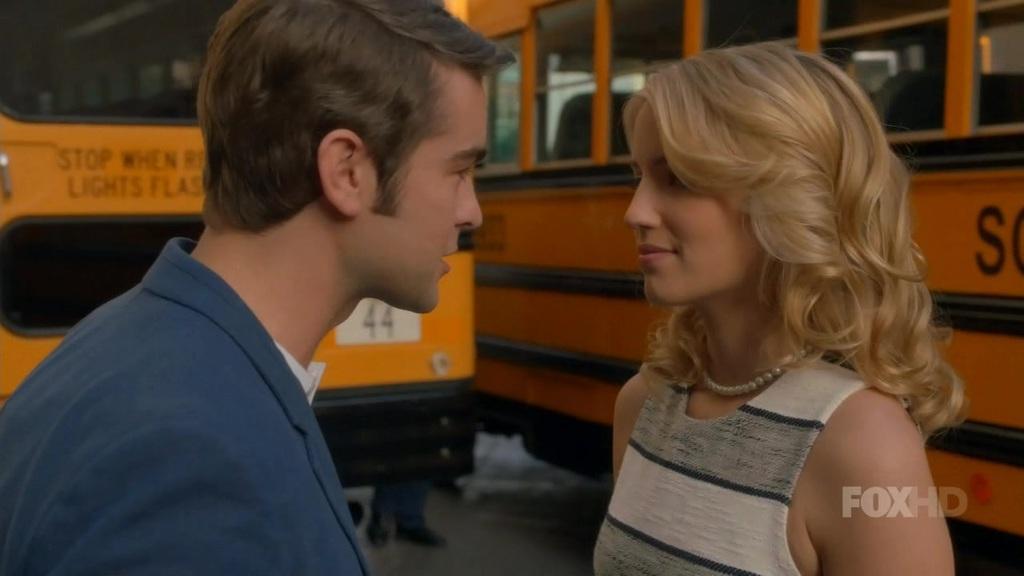Could you give a brief overview of what you see in this image? There are two persons looking at each other and in the background we can see vehicles. 